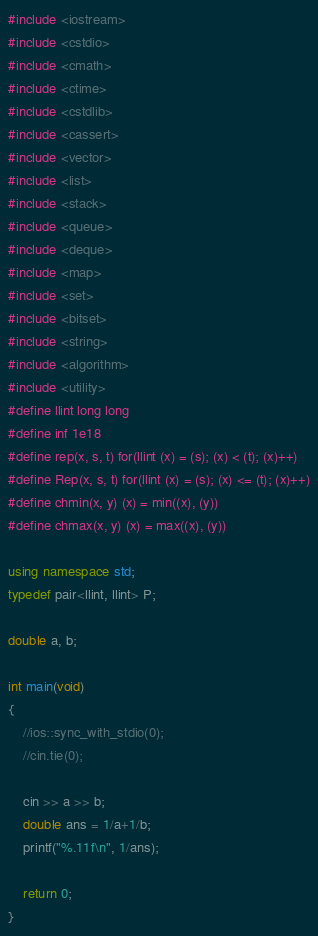Convert code to text. <code><loc_0><loc_0><loc_500><loc_500><_C++_>#include <iostream>
#include <cstdio>
#include <cmath>
#include <ctime>
#include <cstdlib>
#include <cassert>
#include <vector>
#include <list>
#include <stack>
#include <queue>
#include <deque>
#include <map>
#include <set>
#include <bitset>
#include <string>
#include <algorithm>
#include <utility>
#define llint long long
#define inf 1e18
#define rep(x, s, t) for(llint (x) = (s); (x) < (t); (x)++)
#define Rep(x, s, t) for(llint (x) = (s); (x) <= (t); (x)++)
#define chmin(x, y) (x) = min((x), (y))
#define chmax(x, y) (x) = max((x), (y))

using namespace std;
typedef pair<llint, llint> P;

double a, b;

int main(void)
{
	//ios::sync_with_stdio(0);
	//cin.tie(0);
	
	cin >> a >> b;
	double ans = 1/a+1/b;
	printf("%.11f\n", 1/ans);
	
	return 0;
}</code> 